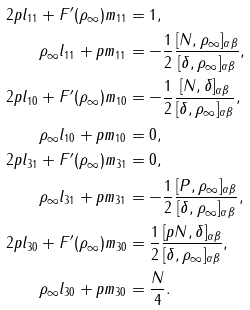Convert formula to latex. <formula><loc_0><loc_0><loc_500><loc_500>2 p l _ { 1 1 } + F ^ { \prime } ( \rho _ { \infty } ) m _ { 1 1 } & = 1 , \\ \rho _ { \infty } l _ { 1 1 } + p m _ { 1 1 } & = - \frac { 1 } { 2 } \frac { [ N , \rho _ { \infty } ] _ { \alpha \beta } } { [ \delta , \rho _ { \infty } ] _ { \alpha \beta } } , \\ 2 p l _ { 1 0 } + F ^ { \prime } ( \rho _ { \infty } ) m _ { 1 0 } & = - \frac { 1 } { 2 } \frac { [ N , \delta ] _ { \alpha \beta } } { [ \delta , \rho _ { \infty } ] _ { \alpha \beta } } , \\ \rho _ { \infty } l _ { 1 0 } + p m _ { 1 0 } & = 0 , \\ 2 p l _ { 3 1 } + F ^ { \prime } ( \rho _ { \infty } ) m _ { 3 1 } & = 0 , \\ \rho _ { \infty } l _ { 3 1 } + p m _ { 3 1 } & = - \frac { 1 } { 2 } \frac { [ P , \rho _ { \infty } ] _ { \alpha \beta } } { [ \delta , \rho _ { \infty } ] _ { \alpha \beta } } , \\ 2 p l _ { 3 0 } + F ^ { \prime } ( \rho _ { \infty } ) m _ { 3 0 } & = \frac { 1 } { 2 } \frac { [ p N , \delta ] _ { \alpha \beta } } { [ \delta , \rho _ { \infty } ] _ { \alpha \beta } } , \\ \rho _ { \infty } l _ { 3 0 } + p m _ { 3 0 } & = \frac { N } { 4 } .</formula> 